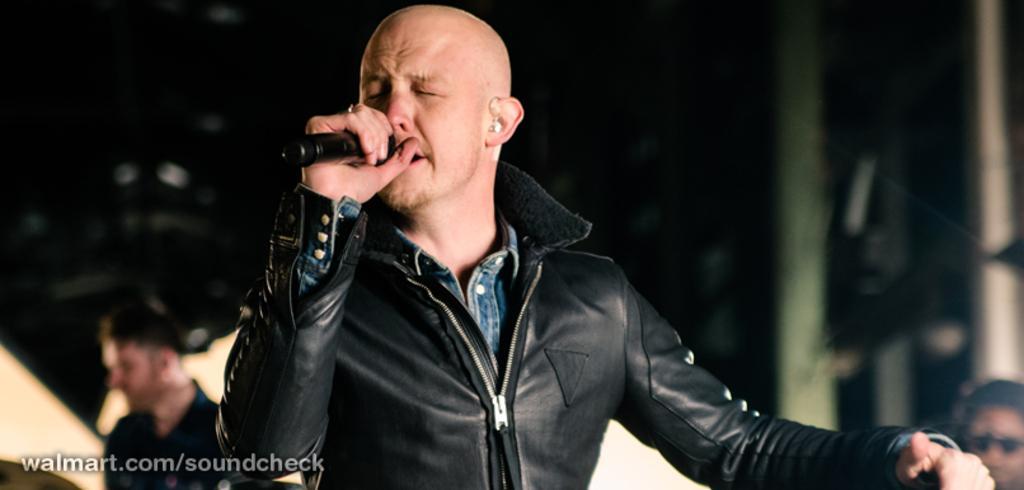In one or two sentences, can you explain what this image depicts? This picture shows a man standing he wore a black coat and holding a microphone in his hand and singing and we see couple of them standing on the sides and we see the watermark at the bottom left of the picture. 